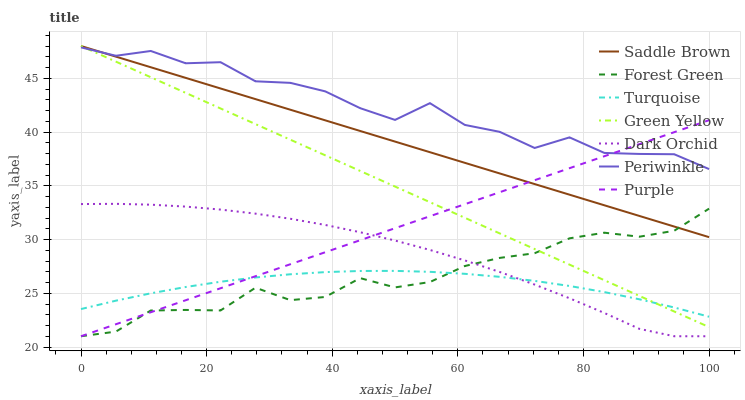Does Purple have the minimum area under the curve?
Answer yes or no. No. Does Purple have the maximum area under the curve?
Answer yes or no. No. Is Dark Orchid the smoothest?
Answer yes or no. No. Is Dark Orchid the roughest?
Answer yes or no. No. Does Periwinkle have the lowest value?
Answer yes or no. No. Does Purple have the highest value?
Answer yes or no. No. Is Turquoise less than Periwinkle?
Answer yes or no. Yes. Is Periwinkle greater than Forest Green?
Answer yes or no. Yes. Does Turquoise intersect Periwinkle?
Answer yes or no. No. 